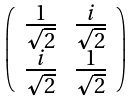<formula> <loc_0><loc_0><loc_500><loc_500>\left ( \begin{array} { c c } \frac { 1 } { \sqrt { 2 } } & \frac { i } { \sqrt { 2 } } \\ \frac { i } { \sqrt { 2 } } & \frac { 1 } { \sqrt { 2 } } \end{array} \right )</formula> 